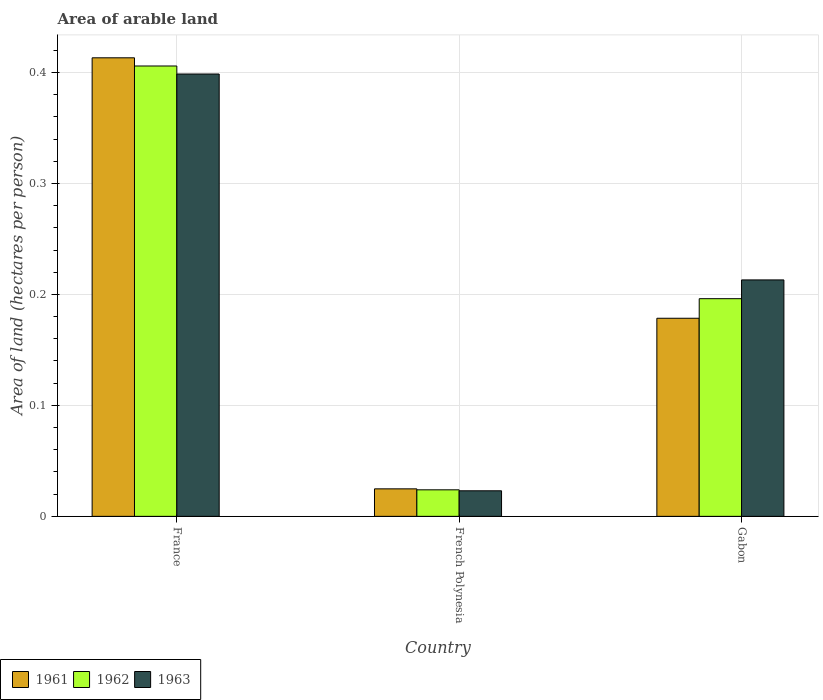How many groups of bars are there?
Make the answer very short. 3. Are the number of bars per tick equal to the number of legend labels?
Offer a terse response. Yes. Are the number of bars on each tick of the X-axis equal?
Offer a very short reply. Yes. How many bars are there on the 1st tick from the left?
Your answer should be very brief. 3. How many bars are there on the 1st tick from the right?
Your response must be concise. 3. What is the label of the 3rd group of bars from the left?
Provide a short and direct response. Gabon. What is the total arable land in 1961 in Gabon?
Provide a short and direct response. 0.18. Across all countries, what is the maximum total arable land in 1961?
Provide a succinct answer. 0.41. Across all countries, what is the minimum total arable land in 1962?
Make the answer very short. 0.02. In which country was the total arable land in 1963 maximum?
Provide a short and direct response. France. In which country was the total arable land in 1963 minimum?
Offer a terse response. French Polynesia. What is the total total arable land in 1963 in the graph?
Provide a short and direct response. 0.63. What is the difference between the total arable land in 1963 in France and that in Gabon?
Provide a succinct answer. 0.19. What is the difference between the total arable land in 1963 in Gabon and the total arable land in 1962 in French Polynesia?
Keep it short and to the point. 0.19. What is the average total arable land in 1963 per country?
Make the answer very short. 0.21. What is the difference between the total arable land of/in 1961 and total arable land of/in 1963 in French Polynesia?
Your answer should be compact. 0. In how many countries, is the total arable land in 1963 greater than 0.16 hectares per person?
Offer a very short reply. 2. What is the ratio of the total arable land in 1961 in France to that in French Polynesia?
Offer a terse response. 16.68. What is the difference between the highest and the second highest total arable land in 1961?
Your answer should be compact. 0.39. What is the difference between the highest and the lowest total arable land in 1962?
Your answer should be compact. 0.38. In how many countries, is the total arable land in 1963 greater than the average total arable land in 1963 taken over all countries?
Provide a short and direct response. 2. How many bars are there?
Make the answer very short. 9. Are all the bars in the graph horizontal?
Make the answer very short. No. Does the graph contain grids?
Your response must be concise. Yes. How are the legend labels stacked?
Keep it short and to the point. Horizontal. What is the title of the graph?
Ensure brevity in your answer.  Area of arable land. Does "1974" appear as one of the legend labels in the graph?
Provide a succinct answer. No. What is the label or title of the X-axis?
Your answer should be compact. Country. What is the label or title of the Y-axis?
Your response must be concise. Area of land (hectares per person). What is the Area of land (hectares per person) in 1961 in France?
Provide a short and direct response. 0.41. What is the Area of land (hectares per person) of 1962 in France?
Offer a very short reply. 0.41. What is the Area of land (hectares per person) in 1963 in France?
Make the answer very short. 0.4. What is the Area of land (hectares per person) of 1961 in French Polynesia?
Make the answer very short. 0.02. What is the Area of land (hectares per person) in 1962 in French Polynesia?
Your answer should be very brief. 0.02. What is the Area of land (hectares per person) in 1963 in French Polynesia?
Your response must be concise. 0.02. What is the Area of land (hectares per person) in 1961 in Gabon?
Ensure brevity in your answer.  0.18. What is the Area of land (hectares per person) in 1962 in Gabon?
Offer a terse response. 0.2. What is the Area of land (hectares per person) of 1963 in Gabon?
Keep it short and to the point. 0.21. Across all countries, what is the maximum Area of land (hectares per person) of 1961?
Give a very brief answer. 0.41. Across all countries, what is the maximum Area of land (hectares per person) in 1962?
Your answer should be very brief. 0.41. Across all countries, what is the maximum Area of land (hectares per person) of 1963?
Your answer should be very brief. 0.4. Across all countries, what is the minimum Area of land (hectares per person) in 1961?
Your answer should be very brief. 0.02. Across all countries, what is the minimum Area of land (hectares per person) in 1962?
Offer a terse response. 0.02. Across all countries, what is the minimum Area of land (hectares per person) in 1963?
Your answer should be compact. 0.02. What is the total Area of land (hectares per person) of 1961 in the graph?
Offer a terse response. 0.62. What is the total Area of land (hectares per person) of 1962 in the graph?
Your answer should be very brief. 0.63. What is the total Area of land (hectares per person) in 1963 in the graph?
Keep it short and to the point. 0.63. What is the difference between the Area of land (hectares per person) of 1961 in France and that in French Polynesia?
Your response must be concise. 0.39. What is the difference between the Area of land (hectares per person) in 1962 in France and that in French Polynesia?
Provide a short and direct response. 0.38. What is the difference between the Area of land (hectares per person) in 1963 in France and that in French Polynesia?
Your answer should be very brief. 0.38. What is the difference between the Area of land (hectares per person) of 1961 in France and that in Gabon?
Ensure brevity in your answer.  0.23. What is the difference between the Area of land (hectares per person) in 1962 in France and that in Gabon?
Provide a succinct answer. 0.21. What is the difference between the Area of land (hectares per person) in 1963 in France and that in Gabon?
Your answer should be compact. 0.19. What is the difference between the Area of land (hectares per person) in 1961 in French Polynesia and that in Gabon?
Offer a very short reply. -0.15. What is the difference between the Area of land (hectares per person) of 1962 in French Polynesia and that in Gabon?
Your response must be concise. -0.17. What is the difference between the Area of land (hectares per person) of 1963 in French Polynesia and that in Gabon?
Your answer should be compact. -0.19. What is the difference between the Area of land (hectares per person) in 1961 in France and the Area of land (hectares per person) in 1962 in French Polynesia?
Provide a succinct answer. 0.39. What is the difference between the Area of land (hectares per person) of 1961 in France and the Area of land (hectares per person) of 1963 in French Polynesia?
Your answer should be very brief. 0.39. What is the difference between the Area of land (hectares per person) in 1962 in France and the Area of land (hectares per person) in 1963 in French Polynesia?
Keep it short and to the point. 0.38. What is the difference between the Area of land (hectares per person) of 1961 in France and the Area of land (hectares per person) of 1962 in Gabon?
Your response must be concise. 0.22. What is the difference between the Area of land (hectares per person) in 1961 in France and the Area of land (hectares per person) in 1963 in Gabon?
Your answer should be compact. 0.2. What is the difference between the Area of land (hectares per person) in 1962 in France and the Area of land (hectares per person) in 1963 in Gabon?
Give a very brief answer. 0.19. What is the difference between the Area of land (hectares per person) in 1961 in French Polynesia and the Area of land (hectares per person) in 1962 in Gabon?
Provide a short and direct response. -0.17. What is the difference between the Area of land (hectares per person) of 1961 in French Polynesia and the Area of land (hectares per person) of 1963 in Gabon?
Keep it short and to the point. -0.19. What is the difference between the Area of land (hectares per person) of 1962 in French Polynesia and the Area of land (hectares per person) of 1963 in Gabon?
Your response must be concise. -0.19. What is the average Area of land (hectares per person) of 1961 per country?
Give a very brief answer. 0.21. What is the average Area of land (hectares per person) in 1962 per country?
Give a very brief answer. 0.21. What is the average Area of land (hectares per person) of 1963 per country?
Provide a short and direct response. 0.21. What is the difference between the Area of land (hectares per person) of 1961 and Area of land (hectares per person) of 1962 in France?
Your answer should be compact. 0.01. What is the difference between the Area of land (hectares per person) in 1961 and Area of land (hectares per person) in 1963 in France?
Your answer should be compact. 0.01. What is the difference between the Area of land (hectares per person) of 1962 and Area of land (hectares per person) of 1963 in France?
Your answer should be very brief. 0.01. What is the difference between the Area of land (hectares per person) in 1961 and Area of land (hectares per person) in 1962 in French Polynesia?
Give a very brief answer. 0. What is the difference between the Area of land (hectares per person) of 1961 and Area of land (hectares per person) of 1963 in French Polynesia?
Provide a succinct answer. 0. What is the difference between the Area of land (hectares per person) in 1962 and Area of land (hectares per person) in 1963 in French Polynesia?
Give a very brief answer. 0. What is the difference between the Area of land (hectares per person) of 1961 and Area of land (hectares per person) of 1962 in Gabon?
Provide a succinct answer. -0.02. What is the difference between the Area of land (hectares per person) of 1961 and Area of land (hectares per person) of 1963 in Gabon?
Make the answer very short. -0.03. What is the difference between the Area of land (hectares per person) in 1962 and Area of land (hectares per person) in 1963 in Gabon?
Provide a short and direct response. -0.02. What is the ratio of the Area of land (hectares per person) of 1961 in France to that in French Polynesia?
Make the answer very short. 16.68. What is the ratio of the Area of land (hectares per person) in 1962 in France to that in French Polynesia?
Provide a short and direct response. 16.98. What is the ratio of the Area of land (hectares per person) of 1963 in France to that in French Polynesia?
Offer a very short reply. 17.31. What is the ratio of the Area of land (hectares per person) in 1961 in France to that in Gabon?
Offer a terse response. 2.31. What is the ratio of the Area of land (hectares per person) in 1962 in France to that in Gabon?
Ensure brevity in your answer.  2.07. What is the ratio of the Area of land (hectares per person) in 1963 in France to that in Gabon?
Keep it short and to the point. 1.87. What is the ratio of the Area of land (hectares per person) of 1961 in French Polynesia to that in Gabon?
Your answer should be compact. 0.14. What is the ratio of the Area of land (hectares per person) of 1962 in French Polynesia to that in Gabon?
Make the answer very short. 0.12. What is the ratio of the Area of land (hectares per person) in 1963 in French Polynesia to that in Gabon?
Keep it short and to the point. 0.11. What is the difference between the highest and the second highest Area of land (hectares per person) of 1961?
Provide a short and direct response. 0.23. What is the difference between the highest and the second highest Area of land (hectares per person) in 1962?
Make the answer very short. 0.21. What is the difference between the highest and the second highest Area of land (hectares per person) in 1963?
Ensure brevity in your answer.  0.19. What is the difference between the highest and the lowest Area of land (hectares per person) in 1961?
Offer a very short reply. 0.39. What is the difference between the highest and the lowest Area of land (hectares per person) of 1962?
Give a very brief answer. 0.38. What is the difference between the highest and the lowest Area of land (hectares per person) of 1963?
Offer a terse response. 0.38. 